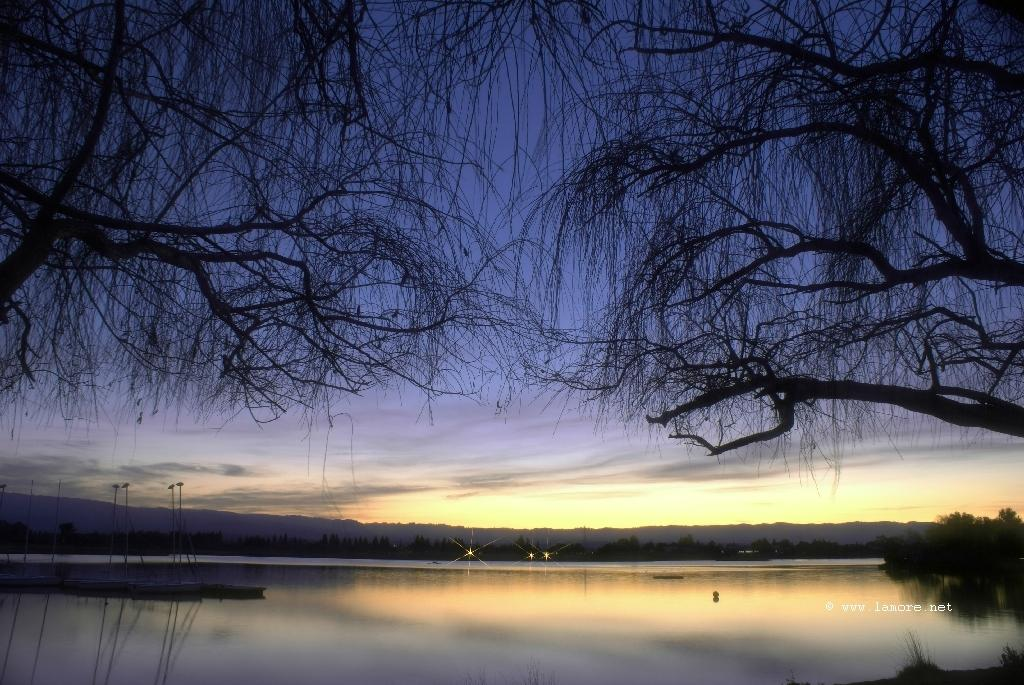What is the primary element present in the image? There is water in the image. What type of natural vegetation can be seen in the image? There are trees in the image. What can be seen in the background of the image? There are lights visible in the background. What is visible at the top of the image? The sky is visible at the top of the image. Where is the rake being used in the image? There is no rake present in the image. How many ships can be seen in the image? There are no ships present in the image. 